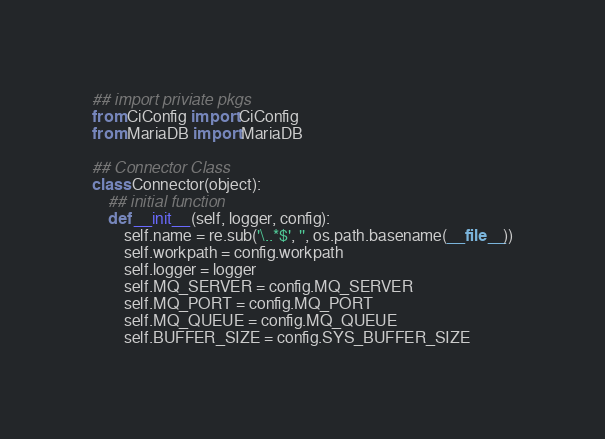Convert code to text. <code><loc_0><loc_0><loc_500><loc_500><_Python_>
## import priviate pkgs
from CiConfig import CiConfig
from MariaDB import MariaDB

## Connector Class
class Connector(object):
    ## initial function
    def __init__(self, logger, config):
        self.name = re.sub('\..*$', '', os.path.basename(__file__))
        self.workpath = config.workpath
        self.logger = logger
        self.MQ_SERVER = config.MQ_SERVER
        self.MQ_PORT = config.MQ_PORT
        self.MQ_QUEUE = config.MQ_QUEUE
        self.BUFFER_SIZE = config.SYS_BUFFER_SIZE</code> 